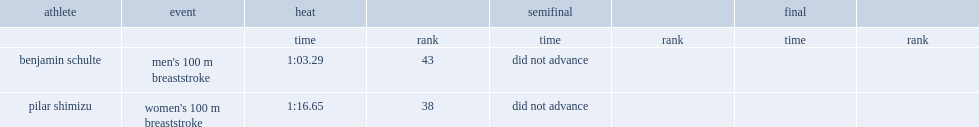What is the final result for benjamin's men's 100 m breaststroke? 1:03.29. 